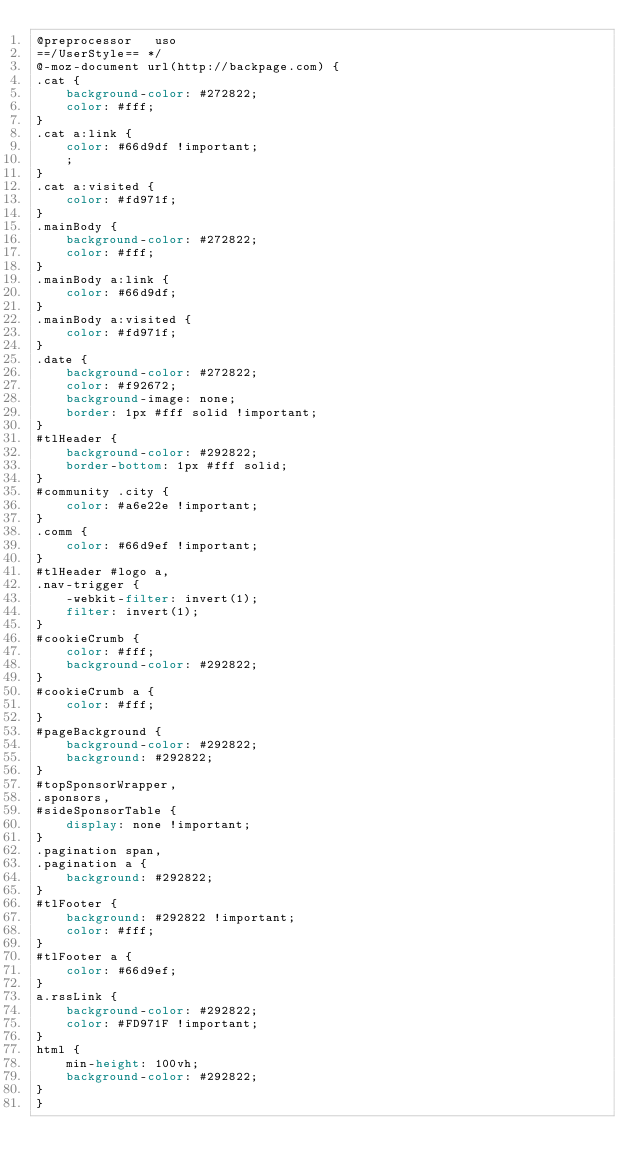<code> <loc_0><loc_0><loc_500><loc_500><_CSS_>@preprocessor   uso
==/UserStyle== */
@-moz-document url(http://backpage.com) {
.cat {
    background-color: #272822;
    color: #fff;
}
.cat a:link {
    color: #66d9df !important;
    ;
}
.cat a:visited {
    color: #fd971f;
}
.mainBody {
    background-color: #272822;
    color: #fff;
}
.mainBody a:link {
    color: #66d9df;
}
.mainBody a:visited {
    color: #fd971f;
}
.date {
    background-color: #272822;
    color: #f92672;
    background-image: none;
    border: 1px #fff solid !important;
}
#tlHeader {
    background-color: #292822;
    border-bottom: 1px #fff solid;
}
#community .city {
    color: #a6e22e !important;
}
.comm {
    color: #66d9ef !important;
}
#tlHeader #logo a,
.nav-trigger {
    -webkit-filter: invert(1);
    filter: invert(1);
}
#cookieCrumb {
    color: #fff;
    background-color: #292822;
}
#cookieCrumb a {
    color: #fff;
}
#pageBackground {
    background-color: #292822;
    background: #292822;
}
#topSponsorWrapper,
.sponsors,
#sideSponsorTable {
    display: none !important;
}
.pagination span,
.pagination a {
    background: #292822;
}
#tlFooter {
    background: #292822 !important;
    color: #fff;
}
#tlFooter a {
    color: #66d9ef;
}
a.rssLink {
    background-color: #292822;
    color: #FD971F !important;
}
html {
    min-height: 100vh;
    background-color: #292822;
}
}</code> 